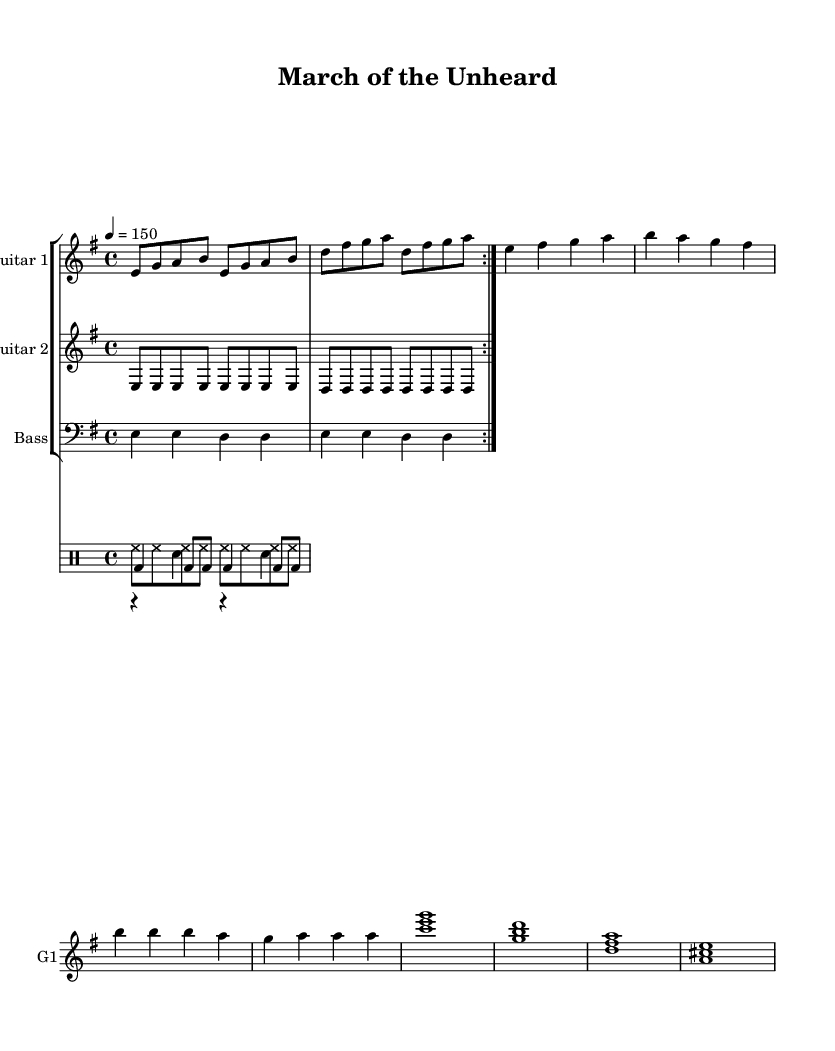What is the key signature of this music? The key signature is specified as E minor, which has one sharp (F#).
Answer: E minor What is the time signature of this music? The time signature is indicated as 4/4, meaning there are four beats in a measure, and the quarter note receives one beat.
Answer: 4/4 What is the tempo marking for this music? The tempo marking shows 4 = 150, meaning the piece should be played at a speed of 150 beats per minute.
Answer: 150 How many times is the main riff repeated? The main riff is indicated with a repeat symbol that states it is to be played twice (volta 2).
Answer: 2 What is the primary instrument used for the melodic line in this piece? The melodic line is primarily indicated for Guitar 1, which plays the main riff and melody parts.
Answer: Guitar 1 What type of chords are used in the bridge section? The bridge section consists of power chords outlined by the staff notation, indicating triadic structures (e.g., C, G, D, A).
Answer: Power chords In which part of the music is the bass line introduced? The bass line is introduced alongside the main riff, as it follows the same pattern as Guitar 1.
Answer: Main riff 